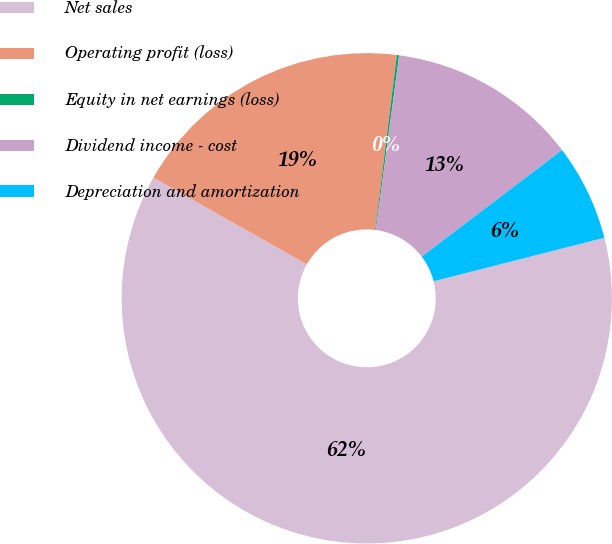Convert chart to OTSL. <chart><loc_0><loc_0><loc_500><loc_500><pie_chart><fcel>Net sales<fcel>Operating profit (loss)<fcel>Equity in net earnings (loss)<fcel>Dividend income - cost<fcel>Depreciation and amortization<nl><fcel>62.17%<fcel>18.76%<fcel>0.15%<fcel>12.56%<fcel>6.36%<nl></chart> 